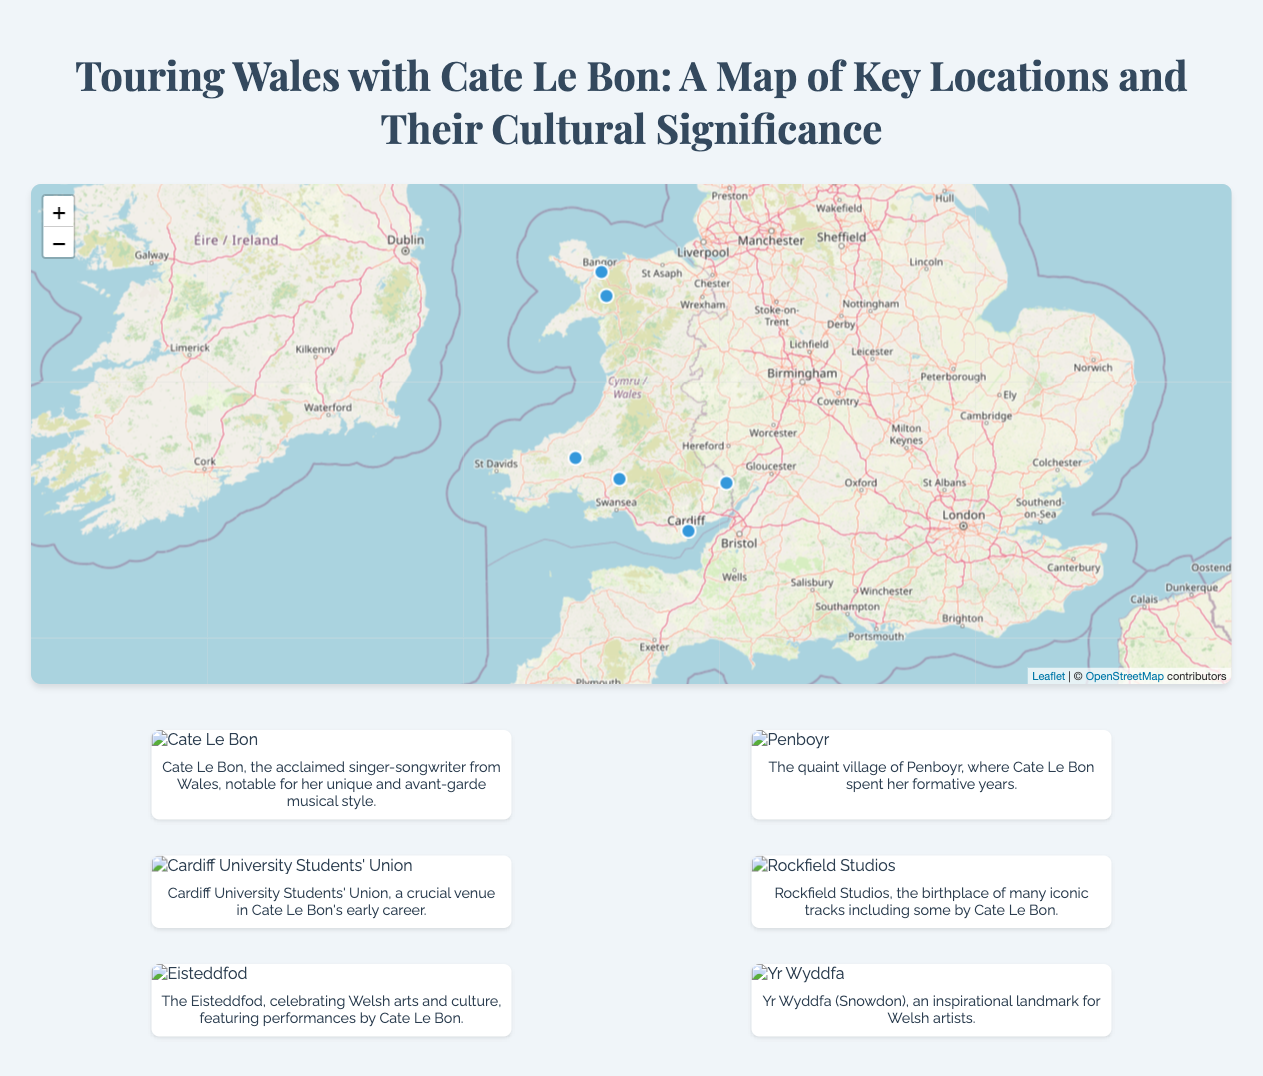what is Cate Le Bon's hometown? Cate Le Bon's hometown is located in Penboyr, as indicated in the document.
Answer: Penboyr which recording studio is mentioned in relation to Cate Le Bon? The document specifies Rockfield Studios as a key location for Cate Le Bon's career.
Answer: Rockfield Studios how many significant locations are highlighted on the map? The document lists six key locations of cultural significance associated with Cate Le Bon.
Answer: six what type of venue is the Cardiff University Students' Union? The Cardiff University Students' Union is described as a concert venue in the infographic.
Answer: Concert Venue which landmark is identified as an inspirational location for Welsh artists? Yr Wyddfa, also known as Snowdon, is highlighted as an inspirational location in the document.
Answer: Yr Wyddfa what type of event is the Eisteddfod? The Eisteddfod is categorized as a cultural festival that features performances by artists like Cate Le Bon.
Answer: Cultural Festival in which city is the Cardiff University Students' Union located? The Cardiff University Students' Union is situated in Cardiff, as mentioned in the infographic.
Answer: Cardiff how is Penboyr described in relation to Cate Le Bon? Penboyr is described as Cate Le Bon's hometown where she spent her formative years.
Answer: formative years what does the document emphasize about Snowdon's significance? The document states that Snowdon serves as an inspirational landmark for Welsh artists like Cate Le Bon.
Answer: Inspirational landmark 